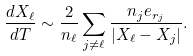Convert formula to latex. <formula><loc_0><loc_0><loc_500><loc_500>\frac { d { X } _ { \ell } } { d T } \sim \frac { 2 } { n _ { \ell } } \sum _ { j \neq { \ell } } \frac { n _ { j } { e } _ { r _ { j } } } { | { X } _ { \ell } - { X } _ { j } | } .</formula> 